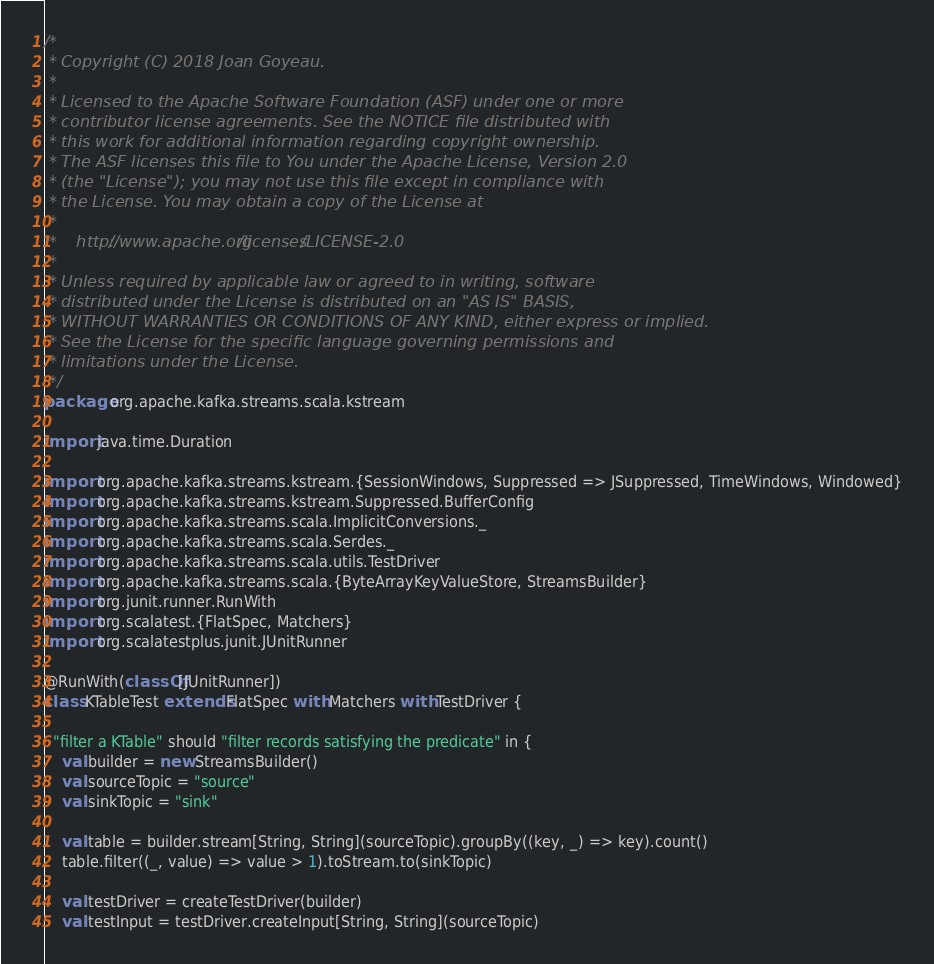Convert code to text. <code><loc_0><loc_0><loc_500><loc_500><_Scala_>/*
 * Copyright (C) 2018 Joan Goyeau.
 *
 * Licensed to the Apache Software Foundation (ASF) under one or more
 * contributor license agreements. See the NOTICE file distributed with
 * this work for additional information regarding copyright ownership.
 * The ASF licenses this file to You under the Apache License, Version 2.0
 * (the "License"); you may not use this file except in compliance with
 * the License. You may obtain a copy of the License at
 *
 *    http://www.apache.org/licenses/LICENSE-2.0
 *
 * Unless required by applicable law or agreed to in writing, software
 * distributed under the License is distributed on an "AS IS" BASIS,
 * WITHOUT WARRANTIES OR CONDITIONS OF ANY KIND, either express or implied.
 * See the License for the specific language governing permissions and
 * limitations under the License.
 */
package org.apache.kafka.streams.scala.kstream

import java.time.Duration

import org.apache.kafka.streams.kstream.{SessionWindows, Suppressed => JSuppressed, TimeWindows, Windowed}
import org.apache.kafka.streams.kstream.Suppressed.BufferConfig
import org.apache.kafka.streams.scala.ImplicitConversions._
import org.apache.kafka.streams.scala.Serdes._
import org.apache.kafka.streams.scala.utils.TestDriver
import org.apache.kafka.streams.scala.{ByteArrayKeyValueStore, StreamsBuilder}
import org.junit.runner.RunWith
import org.scalatest.{FlatSpec, Matchers}
import org.scalatestplus.junit.JUnitRunner

@RunWith(classOf[JUnitRunner])
class KTableTest extends FlatSpec with Matchers with TestDriver {

  "filter a KTable" should "filter records satisfying the predicate" in {
    val builder = new StreamsBuilder()
    val sourceTopic = "source"
    val sinkTopic = "sink"

    val table = builder.stream[String, String](sourceTopic).groupBy((key, _) => key).count()
    table.filter((_, value) => value > 1).toStream.to(sinkTopic)

    val testDriver = createTestDriver(builder)
    val testInput = testDriver.createInput[String, String](sourceTopic)</code> 